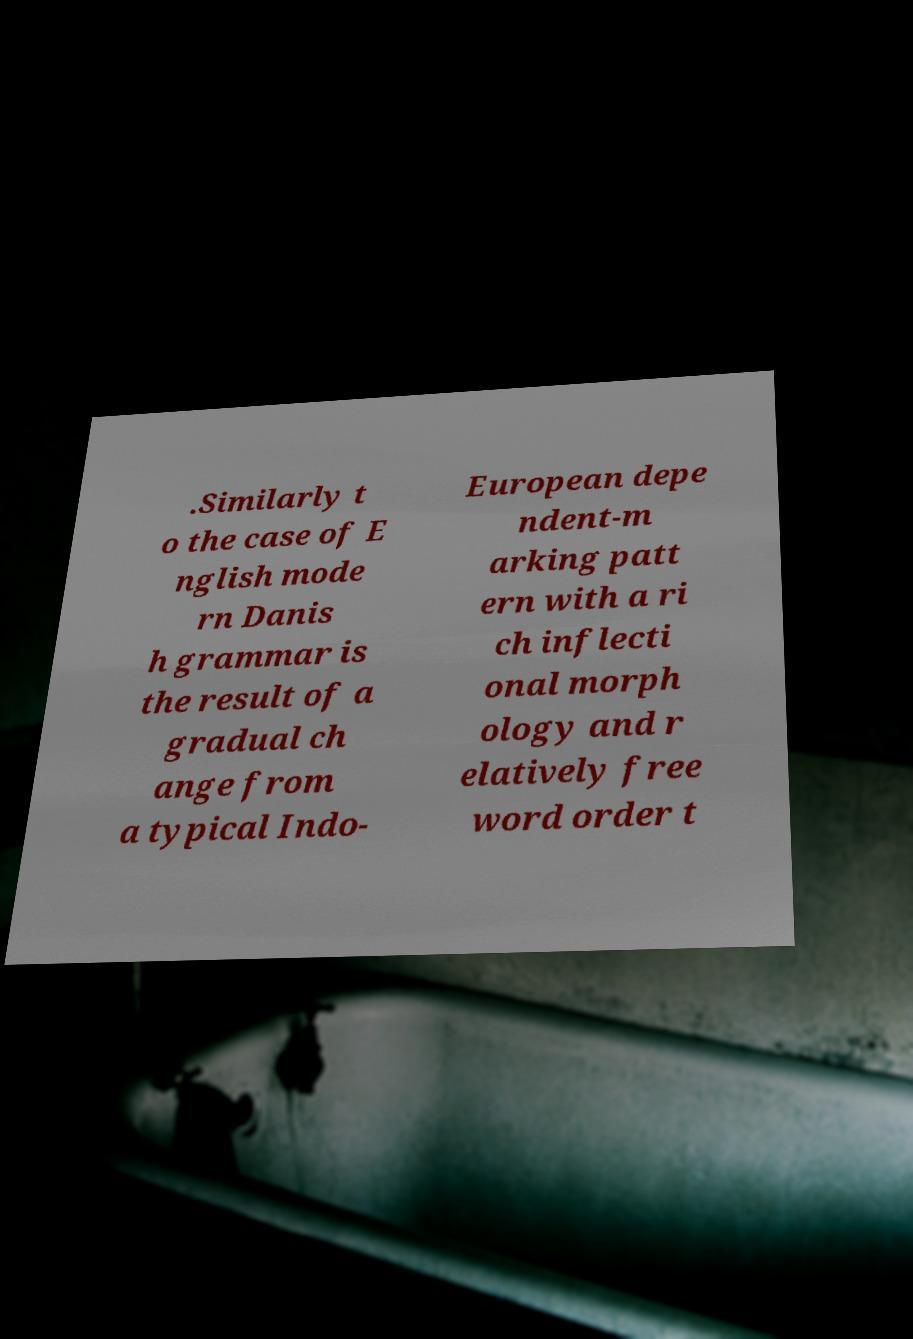Could you extract and type out the text from this image? .Similarly t o the case of E nglish mode rn Danis h grammar is the result of a gradual ch ange from a typical Indo- European depe ndent-m arking patt ern with a ri ch inflecti onal morph ology and r elatively free word order t 